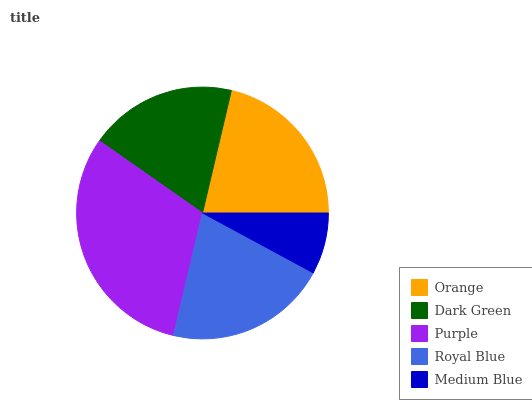Is Medium Blue the minimum?
Answer yes or no. Yes. Is Purple the maximum?
Answer yes or no. Yes. Is Dark Green the minimum?
Answer yes or no. No. Is Dark Green the maximum?
Answer yes or no. No. Is Orange greater than Dark Green?
Answer yes or no. Yes. Is Dark Green less than Orange?
Answer yes or no. Yes. Is Dark Green greater than Orange?
Answer yes or no. No. Is Orange less than Dark Green?
Answer yes or no. No. Is Royal Blue the high median?
Answer yes or no. Yes. Is Royal Blue the low median?
Answer yes or no. Yes. Is Orange the high median?
Answer yes or no. No. Is Orange the low median?
Answer yes or no. No. 